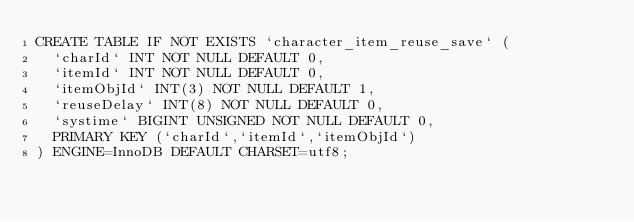Convert code to text. <code><loc_0><loc_0><loc_500><loc_500><_SQL_>CREATE TABLE IF NOT EXISTS `character_item_reuse_save` (
  `charId` INT NOT NULL DEFAULT 0,
  `itemId` INT NOT NULL DEFAULT 0,
  `itemObjId` INT(3) NOT NULL DEFAULT 1,
  `reuseDelay` INT(8) NOT NULL DEFAULT 0,
  `systime` BIGINT UNSIGNED NOT NULL DEFAULT 0,
  PRIMARY KEY (`charId`,`itemId`,`itemObjId`)
) ENGINE=InnoDB DEFAULT CHARSET=utf8;</code> 